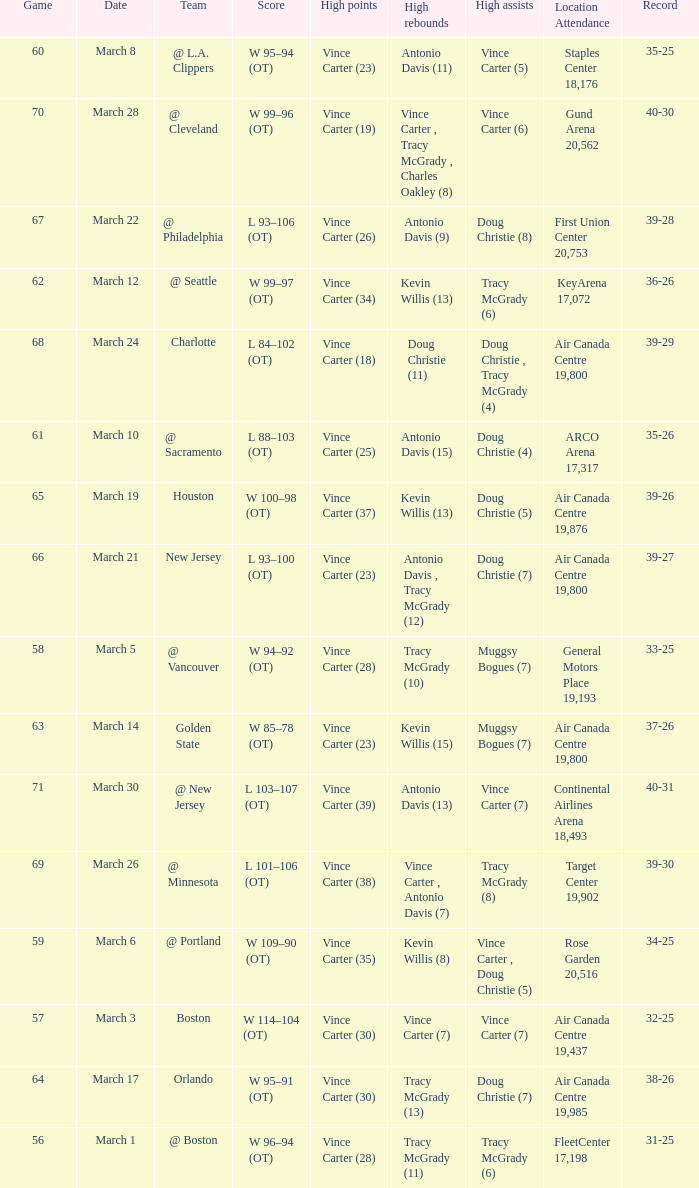Where did the team play and what was the attendance against new jersey? Air Canada Centre 19,800. 